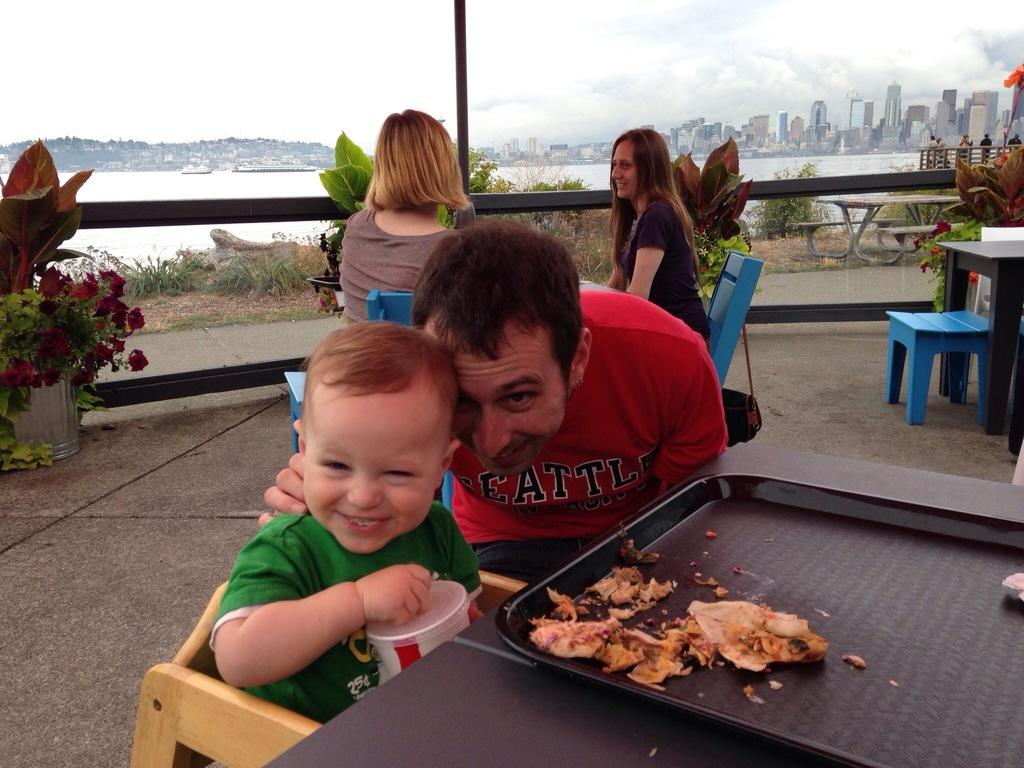How many people are present in the image? There are four people in the image: a man, a child, and two women. What are the people doing in the image? The people are sitting on chairs. What can be seen on the plate in the image? There is food in a plate in the image. What is visible in the background of the image? There are plants, buildings, and water visible in the background of the image. What type of brush is being used by the man in the image? There is no brush present in the image; the man is sitting on a chair with the other people. What type of books can be seen in the library in the image? There is no library present in the image; it features people sitting on chairs with food and a background of plants, buildings, and water. 